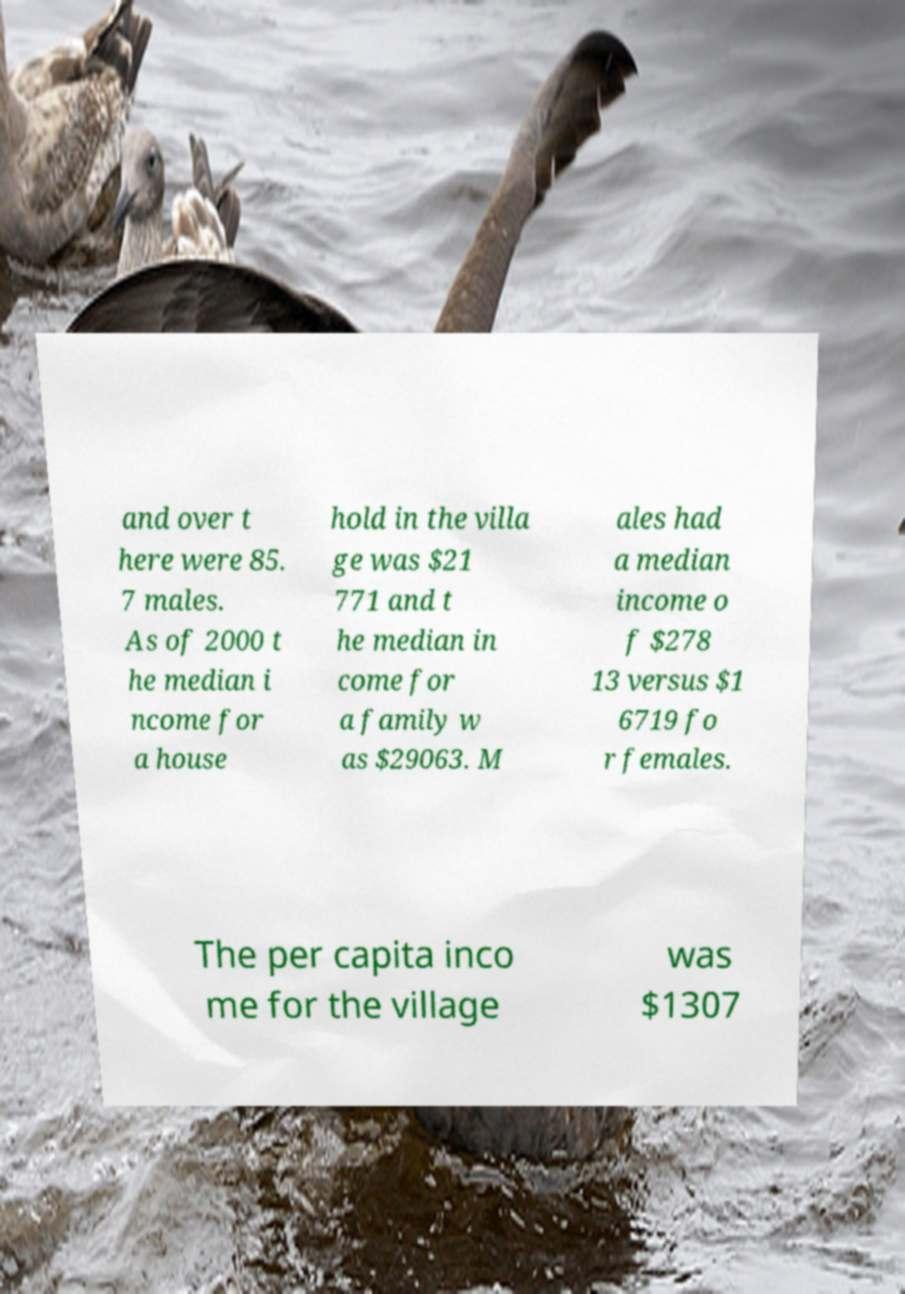I need the written content from this picture converted into text. Can you do that? and over t here were 85. 7 males. As of 2000 t he median i ncome for a house hold in the villa ge was $21 771 and t he median in come for a family w as $29063. M ales had a median income o f $278 13 versus $1 6719 fo r females. The per capita inco me for the village was $1307 